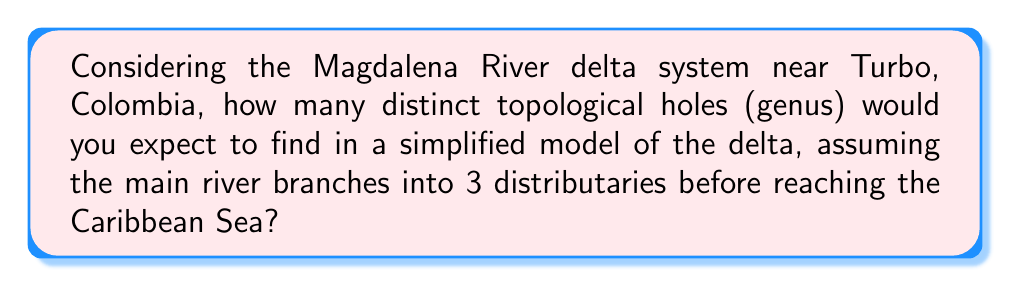What is the answer to this math problem? To analyze this problem, we need to consider the topology of the delta system:

1. The main river starts as a single channel.
2. It branches into 3 distributaries.
3. These distributaries reach the Caribbean Sea.

In topological terms, we can model this system as follows:

1. The main river and its distributaries can be considered as edges.
2. The branching point and the points where the distributaries meet the sea can be considered as vertices.

Let's count:
- Vertices (V): 1 (branching point) + 3 (sea meeting points) = 4
- Edges (E): 1 (main river) + 3 (distributaries) = 4
- Faces (F): We need to determine this

To find the number of faces, we can use the Euler characteristic formula for planar graphs:

$$V - E + F = 2$$

Substituting the known values:

$$4 - 4 + F = 2$$
$$F = 2$$

One of these faces is the exterior (infinite face), so we have one internal face.

The genus (g) of a surface is related to the number of holes. For a planar graph, it's given by:

$$g = 1 - \frac{1}{2}(V - E + F)$$

Substituting our values:

$$g = 1 - \frac{1}{2}(4 - 4 + 2) = 1 - 1 = 0$$

Therefore, in this simplified model, we would expect to find 0 topological holes in the Magdalena River delta system.
Answer: 0 topological holes (genus = 0) 